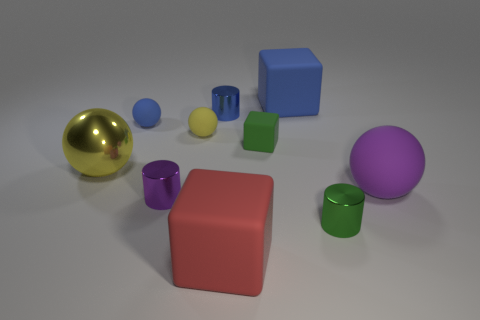Does the cylinder that is behind the tiny blue matte object have the same material as the purple cylinder?
Give a very brief answer. Yes. Is there a large purple rubber object of the same shape as the tiny yellow thing?
Give a very brief answer. Yes. Are there an equal number of blue matte spheres on the right side of the large blue matte block and tiny green rubber cylinders?
Ensure brevity in your answer.  Yes. The green object behind the big object that is left of the tiny purple cylinder is made of what material?
Ensure brevity in your answer.  Rubber. What shape is the small green matte thing?
Make the answer very short. Cube. Are there the same number of spheres behind the small blue shiny cylinder and small blue shiny cylinders that are on the right side of the big yellow metal sphere?
Provide a succinct answer. No. There is a big matte block behind the green block; is its color the same as the matte thing on the right side of the big blue cube?
Keep it short and to the point. No. Are there more big red rubber things left of the big yellow metallic ball than small green blocks?
Make the answer very short. No. There is a purple object that is the same material as the tiny green cube; what is its shape?
Give a very brief answer. Sphere. Does the rubber cube to the right of the green rubber thing have the same size as the purple cylinder?
Your answer should be compact. No. 